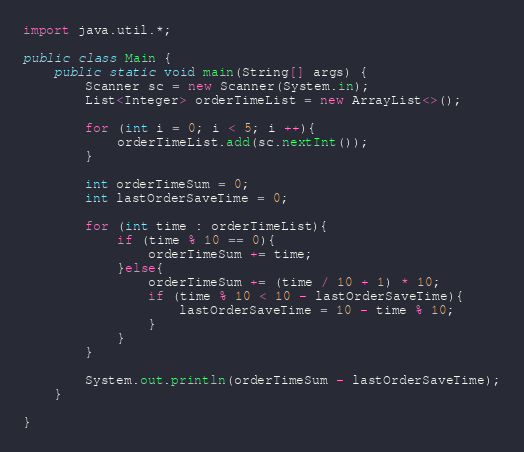<code> <loc_0><loc_0><loc_500><loc_500><_Java_>import java.util.*;

public class Main {
    public static void main(String[] args) {
        Scanner sc = new Scanner(System.in);
        List<Integer> orderTimeList = new ArrayList<>();

        for (int i = 0; i < 5; i ++){
            orderTimeList.add(sc.nextInt());
        }

        int orderTimeSum = 0;
        int lastOrderSaveTime = 0;

        for (int time : orderTimeList){
            if (time % 10 == 0){
                orderTimeSum += time;
            }else{
                orderTimeSum += (time / 10 + 1) * 10;
                if (time % 10 < 10 - lastOrderSaveTime){
                    lastOrderSaveTime = 10 - time % 10;
                }
            }
        }

        System.out.println(orderTimeSum - lastOrderSaveTime);
    }

}</code> 